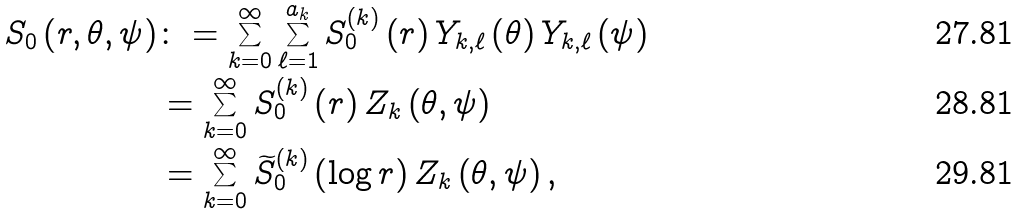Convert formula to latex. <formula><loc_0><loc_0><loc_500><loc_500>S _ { 0 } \left ( r , \theta , \psi \right ) & \colon = \sum _ { k = 0 } ^ { \infty } \sum _ { \ell = 1 } ^ { a _ { k } } S _ { 0 } ^ { \left ( k \right ) } \left ( r \right ) Y _ { k , \ell } \left ( \theta \right ) Y _ { k , \ell } \left ( \psi \right ) \\ & = \sum _ { k = 0 } ^ { \infty } S _ { 0 } ^ { \left ( k \right ) } \left ( r \right ) Z _ { k } \left ( \theta , \psi \right ) \\ & = \sum _ { k = 0 } ^ { \infty } \widetilde { S } _ { 0 } ^ { \left ( k \right ) } \left ( \log r \right ) Z _ { k } \left ( \theta , \psi \right ) ,</formula> 